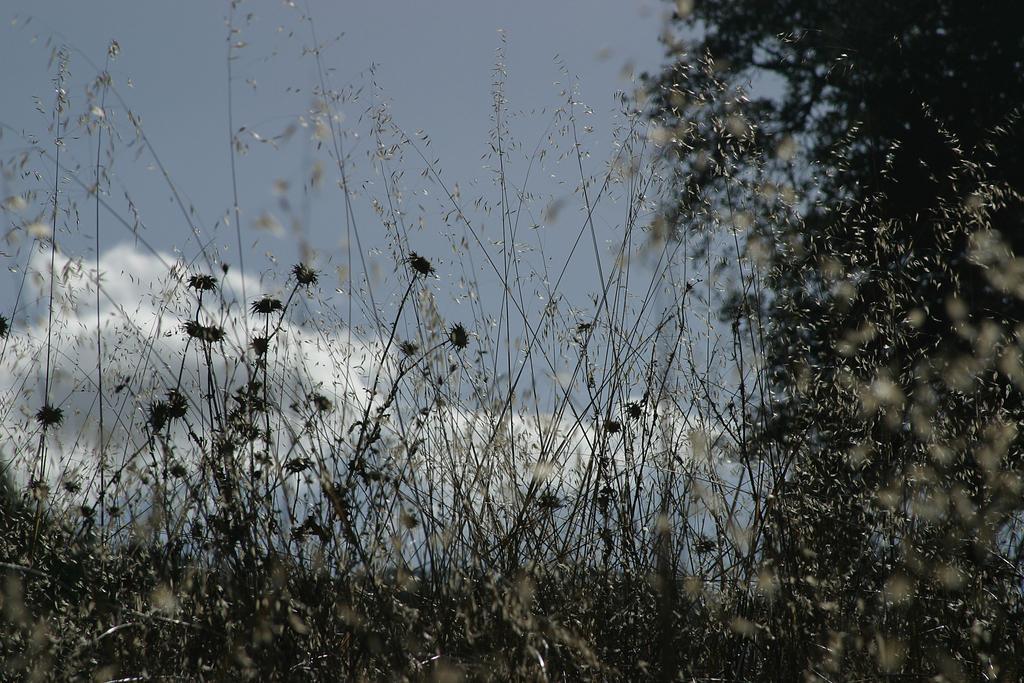Please provide a concise description of this image. We can see plants, flowers and tree. In the background we can see sky with clouds. 